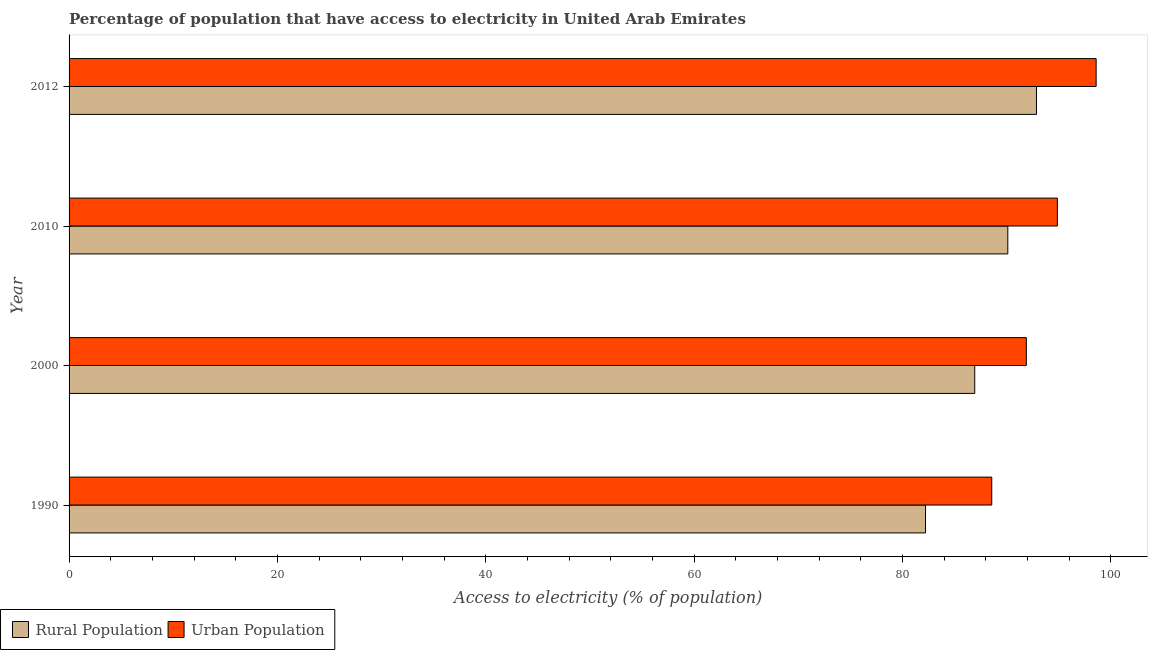Are the number of bars per tick equal to the number of legend labels?
Ensure brevity in your answer.  Yes. How many bars are there on the 1st tick from the bottom?
Make the answer very short. 2. What is the label of the 3rd group of bars from the top?
Your response must be concise. 2000. In how many cases, is the number of bars for a given year not equal to the number of legend labels?
Provide a succinct answer. 0. What is the percentage of rural population having access to electricity in 2012?
Ensure brevity in your answer.  92.85. Across all years, what is the maximum percentage of rural population having access to electricity?
Offer a terse response. 92.85. Across all years, what is the minimum percentage of rural population having access to electricity?
Offer a terse response. 82.2. What is the total percentage of rural population having access to electricity in the graph?
Your answer should be very brief. 352.08. What is the difference between the percentage of urban population having access to electricity in 1990 and that in 2000?
Your answer should be very brief. -3.32. What is the difference between the percentage of rural population having access to electricity in 2000 and the percentage of urban population having access to electricity in 2010?
Keep it short and to the point. -7.93. What is the average percentage of rural population having access to electricity per year?
Make the answer very short. 88.02. In the year 2000, what is the difference between the percentage of rural population having access to electricity and percentage of urban population having access to electricity?
Offer a very short reply. -4.95. In how many years, is the percentage of urban population having access to electricity greater than 64 %?
Make the answer very short. 4. What is the ratio of the percentage of rural population having access to electricity in 1990 to that in 2000?
Keep it short and to the point. 0.95. Is the percentage of rural population having access to electricity in 1990 less than that in 2010?
Ensure brevity in your answer.  Yes. Is the difference between the percentage of urban population having access to electricity in 1990 and 2012 greater than the difference between the percentage of rural population having access to electricity in 1990 and 2012?
Give a very brief answer. Yes. What is the difference between the highest and the second highest percentage of urban population having access to electricity?
Provide a short and direct response. 3.72. What is the difference between the highest and the lowest percentage of rural population having access to electricity?
Give a very brief answer. 10.65. What does the 1st bar from the top in 2012 represents?
Offer a terse response. Urban Population. What does the 2nd bar from the bottom in 2000 represents?
Provide a succinct answer. Urban Population. How many bars are there?
Ensure brevity in your answer.  8. What is the difference between two consecutive major ticks on the X-axis?
Offer a terse response. 20. What is the title of the graph?
Provide a short and direct response. Percentage of population that have access to electricity in United Arab Emirates. Does "Girls" appear as one of the legend labels in the graph?
Your answer should be very brief. No. What is the label or title of the X-axis?
Provide a succinct answer. Access to electricity (% of population). What is the label or title of the Y-axis?
Provide a short and direct response. Year. What is the Access to electricity (% of population) in Rural Population in 1990?
Ensure brevity in your answer.  82.2. What is the Access to electricity (% of population) in Urban Population in 1990?
Make the answer very short. 88.56. What is the Access to electricity (% of population) of Rural Population in 2000?
Make the answer very short. 86.93. What is the Access to electricity (% of population) in Urban Population in 2000?
Provide a short and direct response. 91.88. What is the Access to electricity (% of population) in Rural Population in 2010?
Keep it short and to the point. 90.1. What is the Access to electricity (% of population) of Urban Population in 2010?
Make the answer very short. 94.86. What is the Access to electricity (% of population) in Rural Population in 2012?
Keep it short and to the point. 92.85. What is the Access to electricity (% of population) of Urban Population in 2012?
Provide a succinct answer. 98.58. Across all years, what is the maximum Access to electricity (% of population) in Rural Population?
Provide a succinct answer. 92.85. Across all years, what is the maximum Access to electricity (% of population) in Urban Population?
Offer a terse response. 98.58. Across all years, what is the minimum Access to electricity (% of population) of Rural Population?
Ensure brevity in your answer.  82.2. Across all years, what is the minimum Access to electricity (% of population) of Urban Population?
Offer a terse response. 88.56. What is the total Access to electricity (% of population) of Rural Population in the graph?
Provide a short and direct response. 352.08. What is the total Access to electricity (% of population) of Urban Population in the graph?
Ensure brevity in your answer.  373.87. What is the difference between the Access to electricity (% of population) in Rural Population in 1990 and that in 2000?
Your answer should be compact. -4.72. What is the difference between the Access to electricity (% of population) in Urban Population in 1990 and that in 2000?
Offer a very short reply. -3.32. What is the difference between the Access to electricity (% of population) in Rural Population in 1990 and that in 2010?
Make the answer very short. -7.9. What is the difference between the Access to electricity (% of population) of Urban Population in 1990 and that in 2010?
Ensure brevity in your answer.  -6.3. What is the difference between the Access to electricity (% of population) in Rural Population in 1990 and that in 2012?
Your response must be concise. -10.65. What is the difference between the Access to electricity (% of population) of Urban Population in 1990 and that in 2012?
Make the answer very short. -10.02. What is the difference between the Access to electricity (% of population) of Rural Population in 2000 and that in 2010?
Your response must be concise. -3.17. What is the difference between the Access to electricity (% of population) in Urban Population in 2000 and that in 2010?
Keep it short and to the point. -2.98. What is the difference between the Access to electricity (% of population) in Rural Population in 2000 and that in 2012?
Offer a very short reply. -5.93. What is the difference between the Access to electricity (% of population) in Urban Population in 2000 and that in 2012?
Ensure brevity in your answer.  -6.7. What is the difference between the Access to electricity (% of population) in Rural Population in 2010 and that in 2012?
Offer a very short reply. -2.75. What is the difference between the Access to electricity (% of population) of Urban Population in 2010 and that in 2012?
Your response must be concise. -3.72. What is the difference between the Access to electricity (% of population) in Rural Population in 1990 and the Access to electricity (% of population) in Urban Population in 2000?
Give a very brief answer. -9.67. What is the difference between the Access to electricity (% of population) in Rural Population in 1990 and the Access to electricity (% of population) in Urban Population in 2010?
Offer a terse response. -12.66. What is the difference between the Access to electricity (% of population) of Rural Population in 1990 and the Access to electricity (% of population) of Urban Population in 2012?
Provide a short and direct response. -16.37. What is the difference between the Access to electricity (% of population) of Rural Population in 2000 and the Access to electricity (% of population) of Urban Population in 2010?
Make the answer very short. -7.93. What is the difference between the Access to electricity (% of population) of Rural Population in 2000 and the Access to electricity (% of population) of Urban Population in 2012?
Ensure brevity in your answer.  -11.65. What is the difference between the Access to electricity (% of population) in Rural Population in 2010 and the Access to electricity (% of population) in Urban Population in 2012?
Give a very brief answer. -8.48. What is the average Access to electricity (% of population) in Rural Population per year?
Provide a succinct answer. 88.02. What is the average Access to electricity (% of population) in Urban Population per year?
Make the answer very short. 93.47. In the year 1990, what is the difference between the Access to electricity (% of population) of Rural Population and Access to electricity (% of population) of Urban Population?
Your answer should be very brief. -6.36. In the year 2000, what is the difference between the Access to electricity (% of population) of Rural Population and Access to electricity (% of population) of Urban Population?
Your answer should be very brief. -4.95. In the year 2010, what is the difference between the Access to electricity (% of population) in Rural Population and Access to electricity (% of population) in Urban Population?
Your answer should be compact. -4.76. In the year 2012, what is the difference between the Access to electricity (% of population) of Rural Population and Access to electricity (% of population) of Urban Population?
Keep it short and to the point. -5.72. What is the ratio of the Access to electricity (% of population) of Rural Population in 1990 to that in 2000?
Ensure brevity in your answer.  0.95. What is the ratio of the Access to electricity (% of population) in Urban Population in 1990 to that in 2000?
Offer a very short reply. 0.96. What is the ratio of the Access to electricity (% of population) of Rural Population in 1990 to that in 2010?
Offer a terse response. 0.91. What is the ratio of the Access to electricity (% of population) of Urban Population in 1990 to that in 2010?
Your answer should be very brief. 0.93. What is the ratio of the Access to electricity (% of population) in Rural Population in 1990 to that in 2012?
Provide a short and direct response. 0.89. What is the ratio of the Access to electricity (% of population) of Urban Population in 1990 to that in 2012?
Ensure brevity in your answer.  0.9. What is the ratio of the Access to electricity (% of population) of Rural Population in 2000 to that in 2010?
Give a very brief answer. 0.96. What is the ratio of the Access to electricity (% of population) in Urban Population in 2000 to that in 2010?
Make the answer very short. 0.97. What is the ratio of the Access to electricity (% of population) of Rural Population in 2000 to that in 2012?
Ensure brevity in your answer.  0.94. What is the ratio of the Access to electricity (% of population) of Urban Population in 2000 to that in 2012?
Keep it short and to the point. 0.93. What is the ratio of the Access to electricity (% of population) in Rural Population in 2010 to that in 2012?
Offer a very short reply. 0.97. What is the ratio of the Access to electricity (% of population) in Urban Population in 2010 to that in 2012?
Your answer should be very brief. 0.96. What is the difference between the highest and the second highest Access to electricity (% of population) in Rural Population?
Ensure brevity in your answer.  2.75. What is the difference between the highest and the second highest Access to electricity (% of population) in Urban Population?
Your answer should be compact. 3.72. What is the difference between the highest and the lowest Access to electricity (% of population) of Rural Population?
Your response must be concise. 10.65. What is the difference between the highest and the lowest Access to electricity (% of population) of Urban Population?
Your answer should be compact. 10.02. 